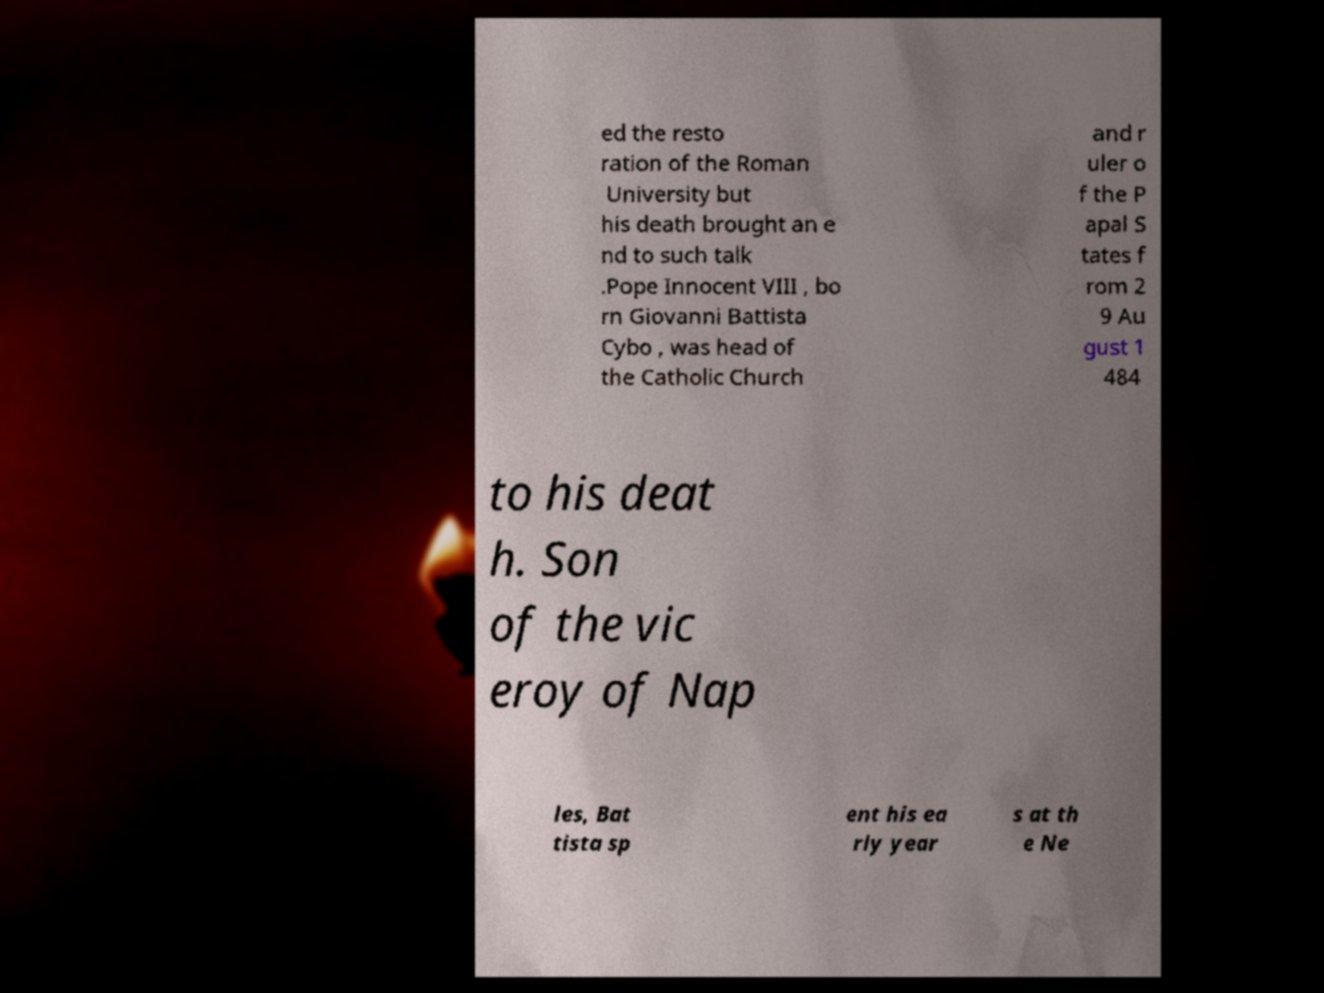Could you assist in decoding the text presented in this image and type it out clearly? ed the resto ration of the Roman University but his death brought an e nd to such talk .Pope Innocent VIII , bo rn Giovanni Battista Cybo , was head of the Catholic Church and r uler o f the P apal S tates f rom 2 9 Au gust 1 484 to his deat h. Son of the vic eroy of Nap les, Bat tista sp ent his ea rly year s at th e Ne 